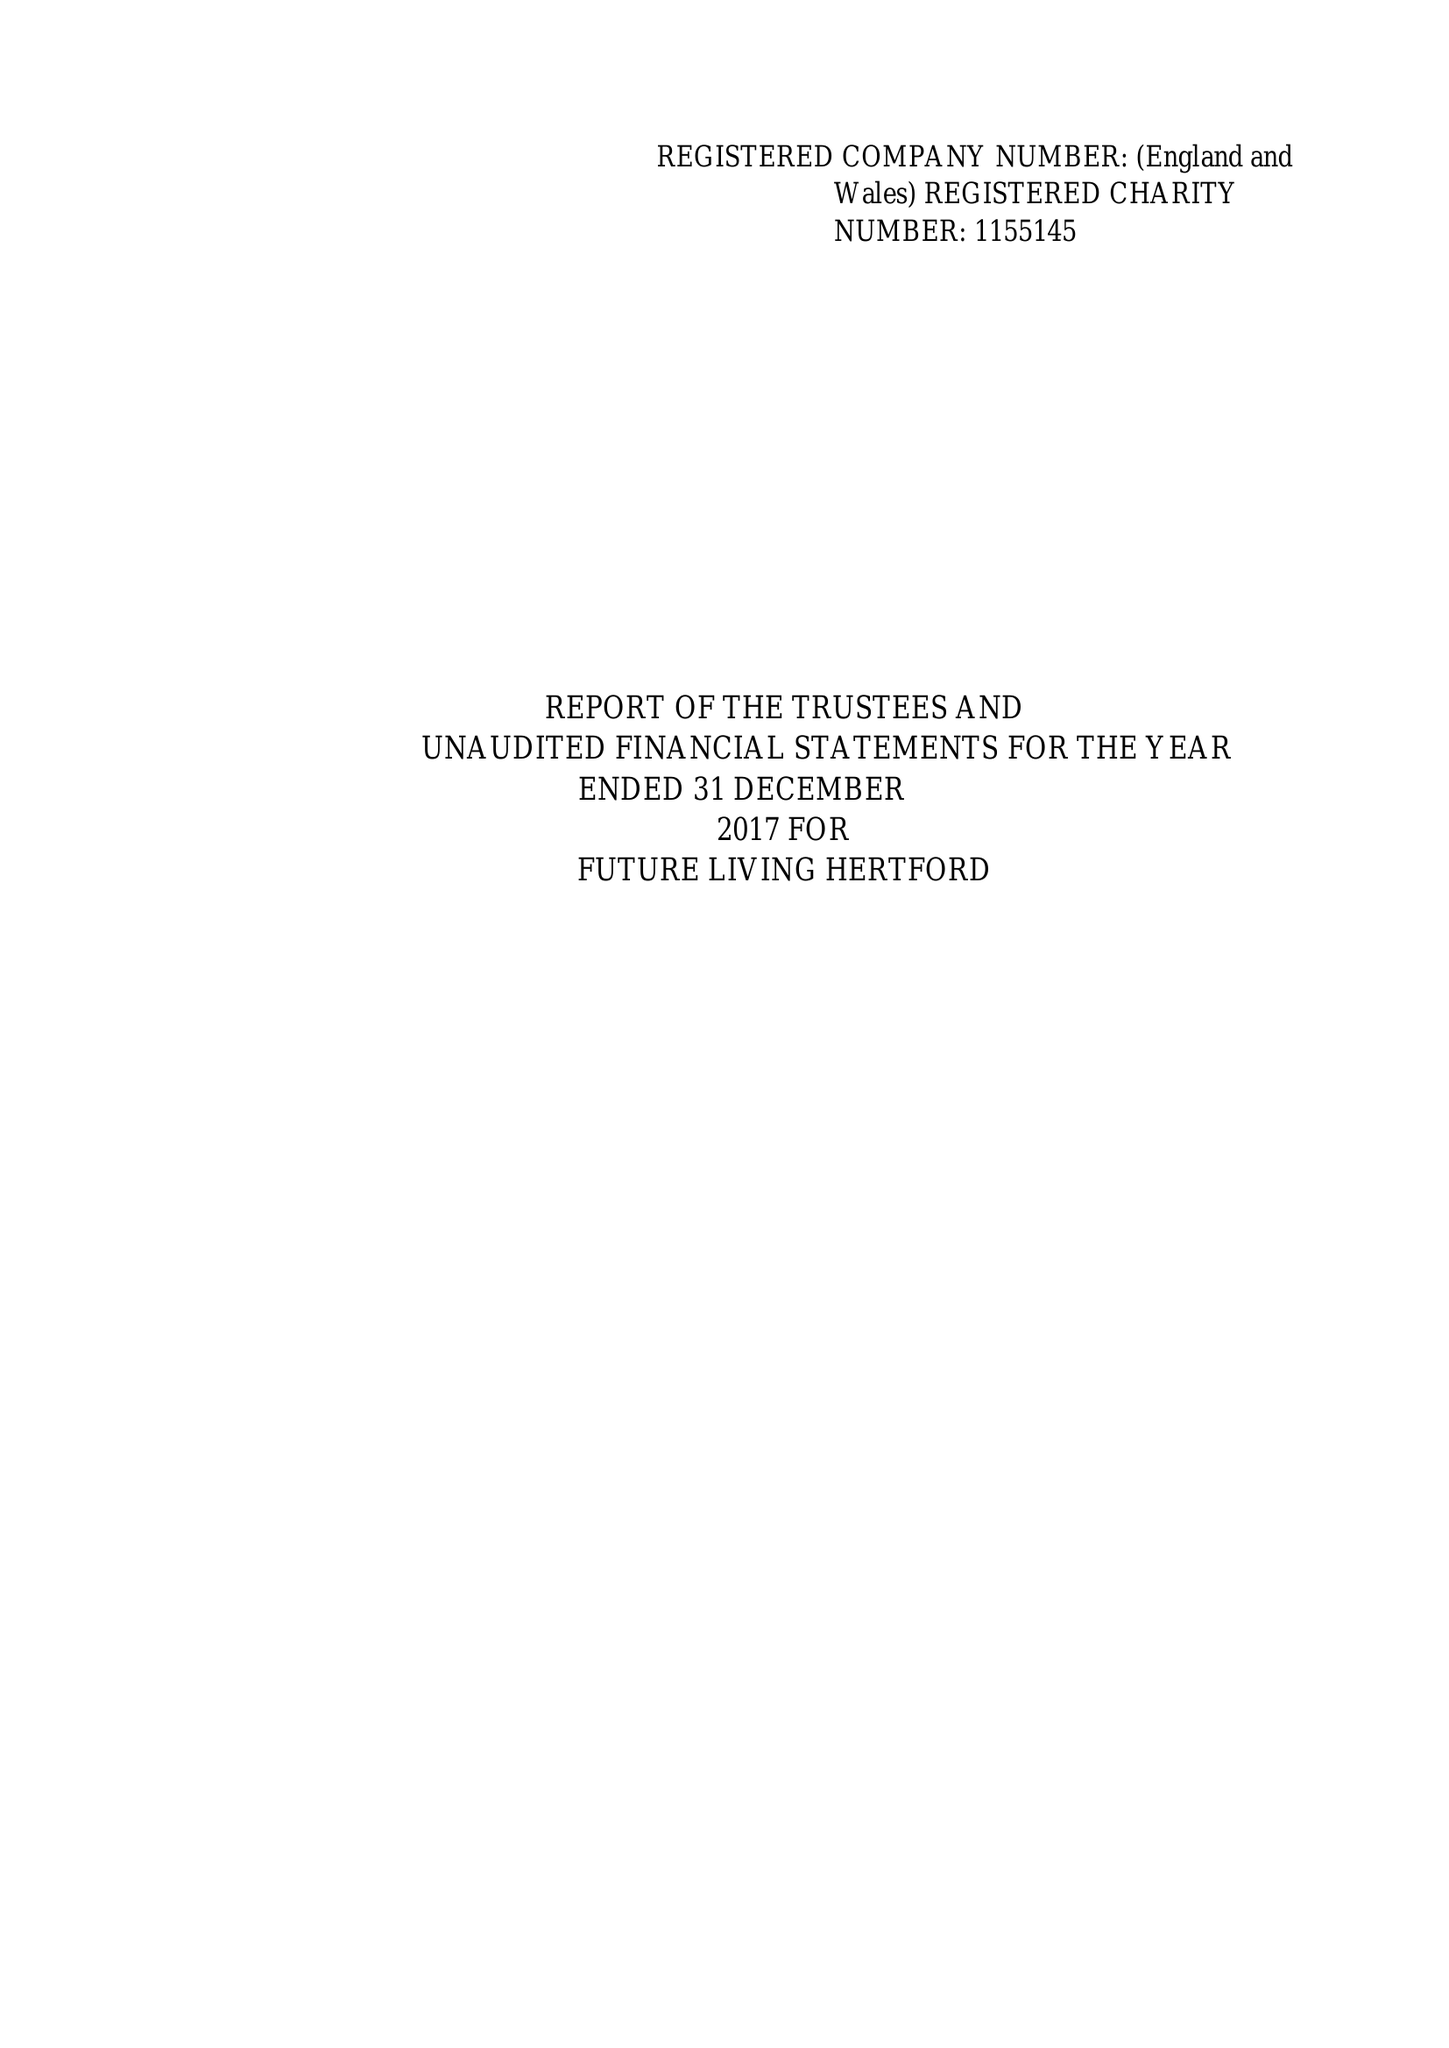What is the value for the address__postcode?
Answer the question using a single word or phrase. SG14 1PN 